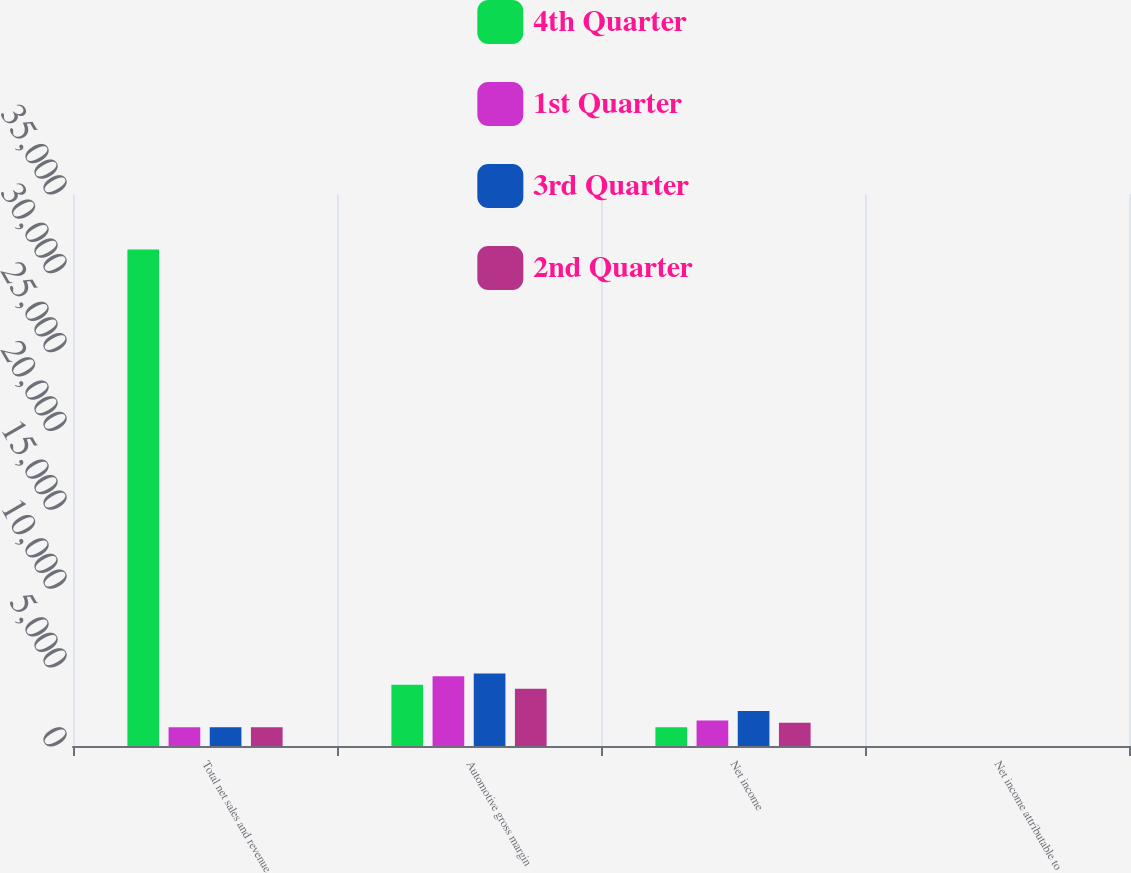Convert chart to OTSL. <chart><loc_0><loc_0><loc_500><loc_500><stacked_bar_chart><ecel><fcel>Total net sales and revenue<fcel>Automotive gross margin<fcel>Net income<fcel>Net income attributable to<nl><fcel>4th Quarter<fcel>31476<fcel>3885<fcel>1196<fcel>0.55<nl><fcel>1st Quarter<fcel>1196<fcel>4415<fcel>1612<fcel>0.85<nl><fcel>3rd Quarter<fcel>1196<fcel>4592<fcel>2223<fcel>1.2<nl><fcel>2nd Quarter<fcel>1196<fcel>3627<fcel>1472<fcel>0.31<nl></chart> 